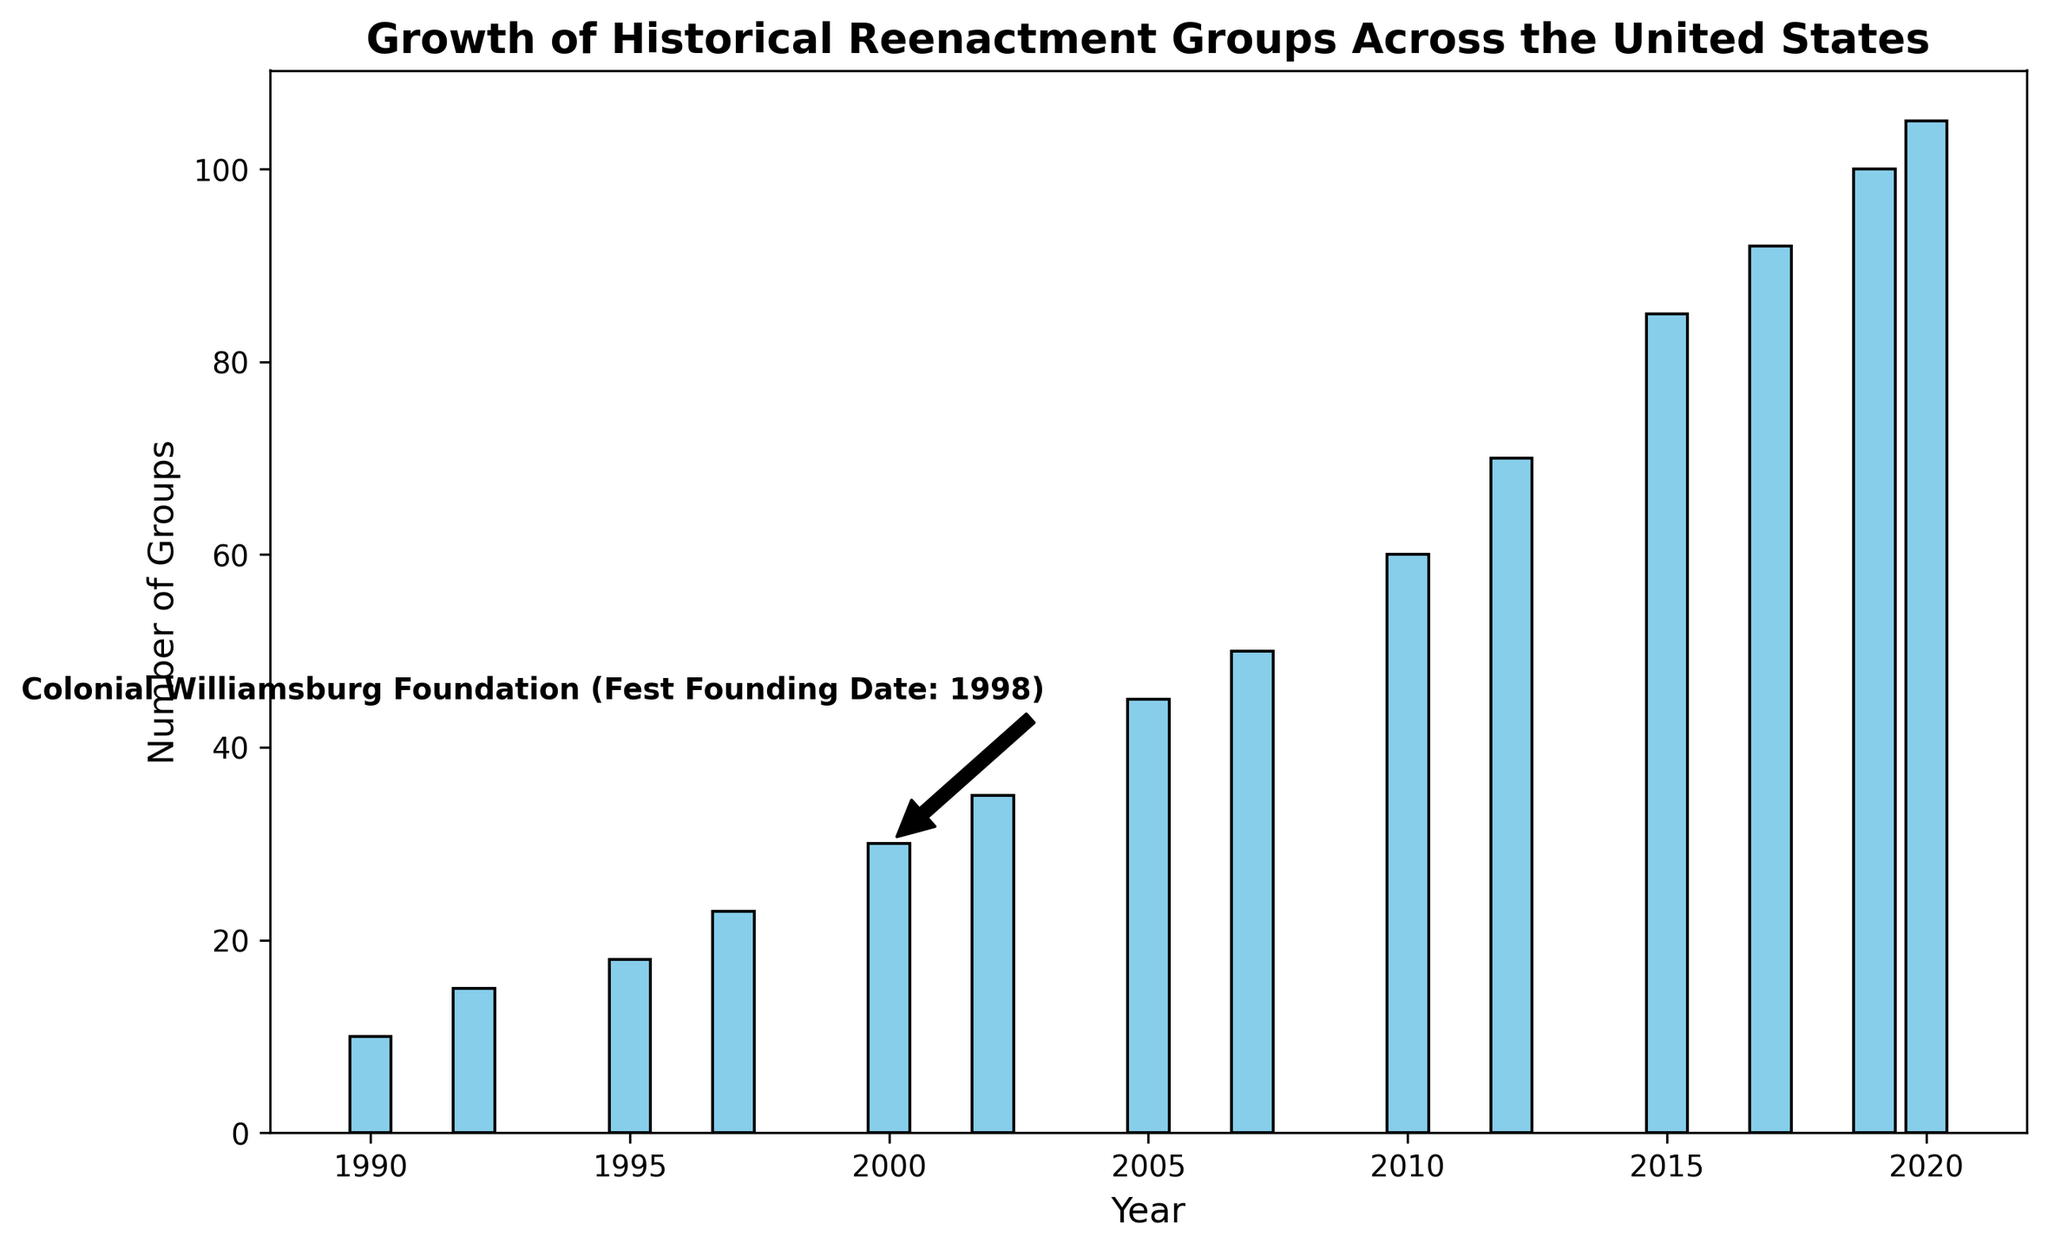What is the number of historical reenactment groups in 2007? The bar corresponding to the year 2007 shows a height reaching up to 50 on the vertical axis, indicating the number of groups.
Answer: 50 How many more reenactment groups were there in 2015 compared to 2005? The number of groups in 2015 is 85 and in 2005 is 45. Subtracting the groups of 2005 from 2015, we get 85 - 45 = 40.
Answer: 40 What is the first year mentioned in the figure? From the x-axis, the first year listed is 1990.
Answer: 1990 Which year saw the founding of the Renaissance Pleasure Faire, according to the annotation? The annotation near the year 2010 mentions "Renaissance Pleasure Faire (Fest Founding Date: 2004)," indicating that the Renaissance Pleasure Faire was founded in 2004.
Answer: 2004 Between 2000 and 2002, by how much did the number of historical reenactment groups increase? The number of groups in 2000 is 30 and in 2002 is 35. Subtracting the two, we get 35 - 30 = 5.
Answer: 5 During which year did the number of groups first reach 100? According to the height of the bars, the number of groups reached 100 in the year 2019.
Answer: 2019 What is the title of the annotated festival that was founded in 1998? The annotation text around the year 2017 indicates "Gettysburg Civil War Reenactment (Fest Founding Date: 1998)," pointing out that this festival was founded in 1998.
Answer: Gettysburg Civil War Reenactment Comparing the years 2017 and 2020, how many more groups were there in 2020? The number of groups in 2017 is 92 and in 2020 is 105. Subtracting, we get 105 - 92 = 13.
Answer: 13 How did the number of groups change from 1990 to 2000? The number of groups in 1990 is 10, and in 2000 it is 30. Subtracting, we get 30 - 10 = 20, indicating an increase of 20.
Answer: Increased by 20 How many years after the founding of the Colonial Williamsburg Foundation festival did the number of groups reach 100? The Colonial Williamsburg Foundation festival was founded in 1998, and the number of groups reached 100 in 2019. Subtracting the years, 2019 - 1998 = 21 years.
Answer: 21 years 